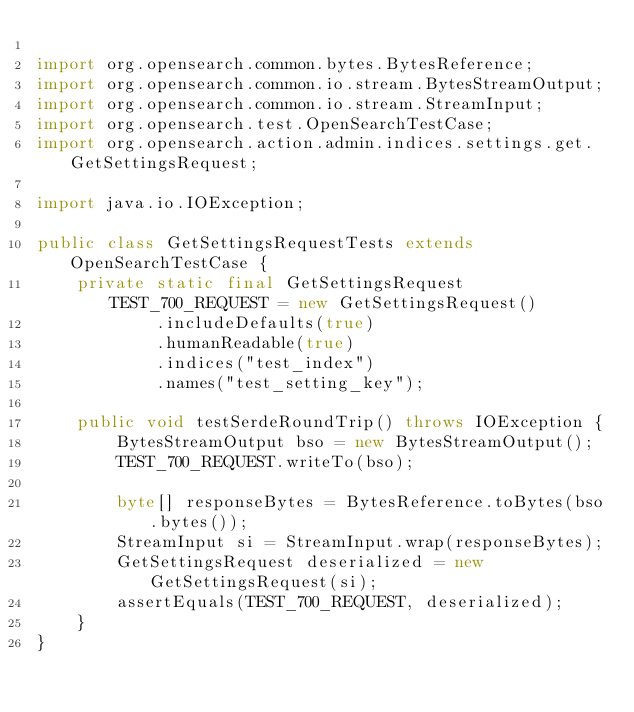<code> <loc_0><loc_0><loc_500><loc_500><_Java_>
import org.opensearch.common.bytes.BytesReference;
import org.opensearch.common.io.stream.BytesStreamOutput;
import org.opensearch.common.io.stream.StreamInput;
import org.opensearch.test.OpenSearchTestCase;
import org.opensearch.action.admin.indices.settings.get.GetSettingsRequest;

import java.io.IOException;

public class GetSettingsRequestTests extends OpenSearchTestCase {
    private static final GetSettingsRequest TEST_700_REQUEST = new GetSettingsRequest()
            .includeDefaults(true)
            .humanReadable(true)
            .indices("test_index")
            .names("test_setting_key");

    public void testSerdeRoundTrip() throws IOException {
        BytesStreamOutput bso = new BytesStreamOutput();
        TEST_700_REQUEST.writeTo(bso);

        byte[] responseBytes = BytesReference.toBytes(bso.bytes());
        StreamInput si = StreamInput.wrap(responseBytes);
        GetSettingsRequest deserialized = new GetSettingsRequest(si);
        assertEquals(TEST_700_REQUEST, deserialized);
    }
}
</code> 